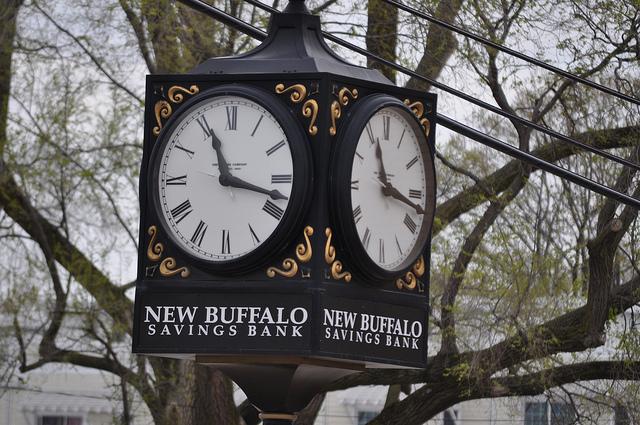Are both clocks displaying the same time?
Short answer required. Yes. Is it daytime?
Quick response, please. Yes. What is the name of the Bank advertised?
Be succinct. New buffalo savings bank. What kind of business is being advertised here?
Write a very short answer. Bank. 